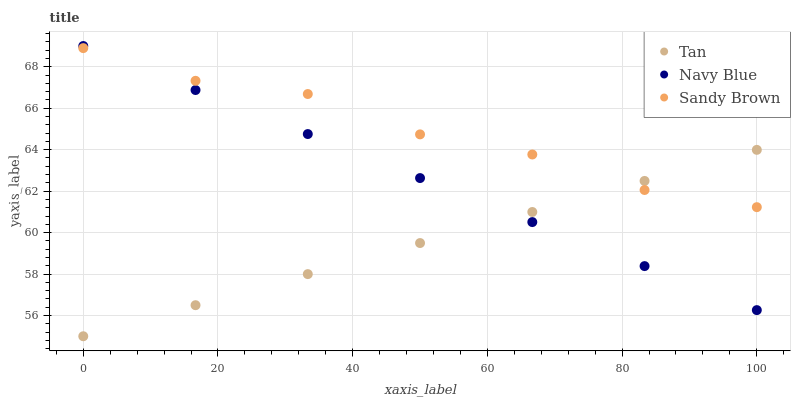Does Tan have the minimum area under the curve?
Answer yes or no. Yes. Does Sandy Brown have the maximum area under the curve?
Answer yes or no. Yes. Does Sandy Brown have the minimum area under the curve?
Answer yes or no. No. Does Tan have the maximum area under the curve?
Answer yes or no. No. Is Navy Blue the smoothest?
Answer yes or no. Yes. Is Sandy Brown the roughest?
Answer yes or no. Yes. Is Tan the smoothest?
Answer yes or no. No. Is Tan the roughest?
Answer yes or no. No. Does Tan have the lowest value?
Answer yes or no. Yes. Does Sandy Brown have the lowest value?
Answer yes or no. No. Does Navy Blue have the highest value?
Answer yes or no. Yes. Does Sandy Brown have the highest value?
Answer yes or no. No. Does Navy Blue intersect Sandy Brown?
Answer yes or no. Yes. Is Navy Blue less than Sandy Brown?
Answer yes or no. No. Is Navy Blue greater than Sandy Brown?
Answer yes or no. No. 